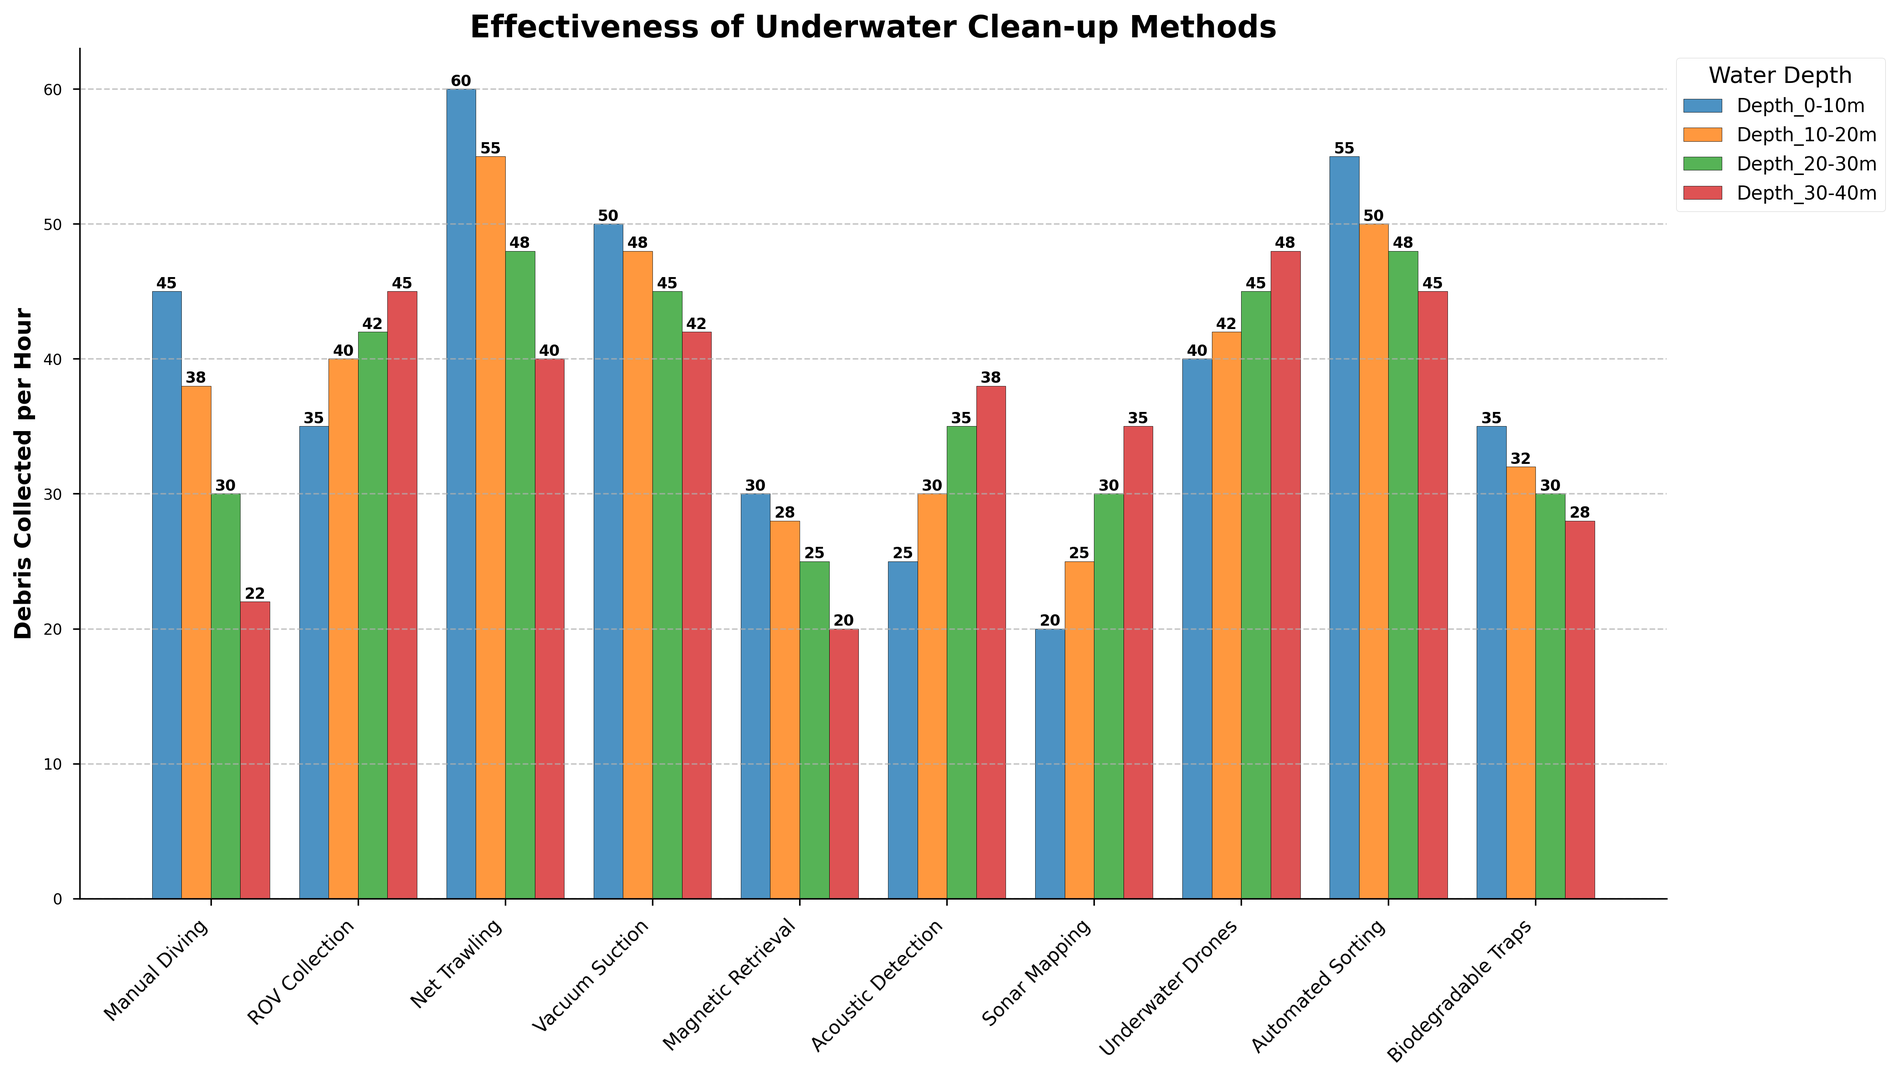Which method collects the most debris at Depth 0-10m? Look at the highest bar in the Depth 0-10m group (dark blue bars). The highest bar corresponds to Net Trawling.
Answer: Net Trawling How much more debris does Manual Diving collect at Depth 0-10m compared to Depth 30-40m? Check the bars for Manual Diving at Depth 0-10m and Depth 30-40m. The values are 45 and 22, respectively. The difference is 45 - 22.
Answer: 23 Which method shows the least variation in debris collected across all depths? Compare the heights of the bars for each method across all depths. The method with bars closest in height is Acoustic Detection.
Answer: Acoustic Detection What's the total amount of debris collected by Automated Sorting at all depths? Add the heights of the bars for Automated Sorting at each depth: 55 (0-10m) + 50 (10-20m) + 48 (20-30m) + 45 (30-40m).
Answer: 198 How much debris does Underwater Drones collect on average across all depths? Add the values for Underwater Drones at all depths and divide by the number of depths: (40 + 42 + 45 + 48) / 4.
Answer: 43.75 Which method collects the least debris at Depth 20-30m? Look at the smallest bar in the Depth 20-30m group (green bars). The lowest value corresponds to Magnetic Retrieval.
Answer: Magnetic Retrieval Does Vacuum Suction collect more debris at Depth 20-30m than Sonar Mapping at Depth 30-40m? Compare the values: Vacuum Suction at Depth 20-30m is 45 and Sonar Mapping at Depth 30-40m is 35.
Answer: Yes What's the sum of debris collected by Magnetic Retrieval at Depth 0-10m and ROV Collection at Depth 30-40m? Add Magnetic Retrieval at Depth 0-10m (30) and ROV Collection at Depth 30-40m (45).
Answer: 75 Which method has the highest sum total of debris collected at Depth 10-20m and Depth 20-30m? Add the values for each method at Depth 10-20m and Depth 20-30m, and compare. Automated Sorting: 50 + 48 = 98. Others are lower.
Answer: Automated Sorting Which depth range shows the highest collection for Net Trawling? Compare all bars for Net Trawling across the depths. The highest bar is at Depth 0-10m with a value of 60.
Answer: Depth 0-10m 